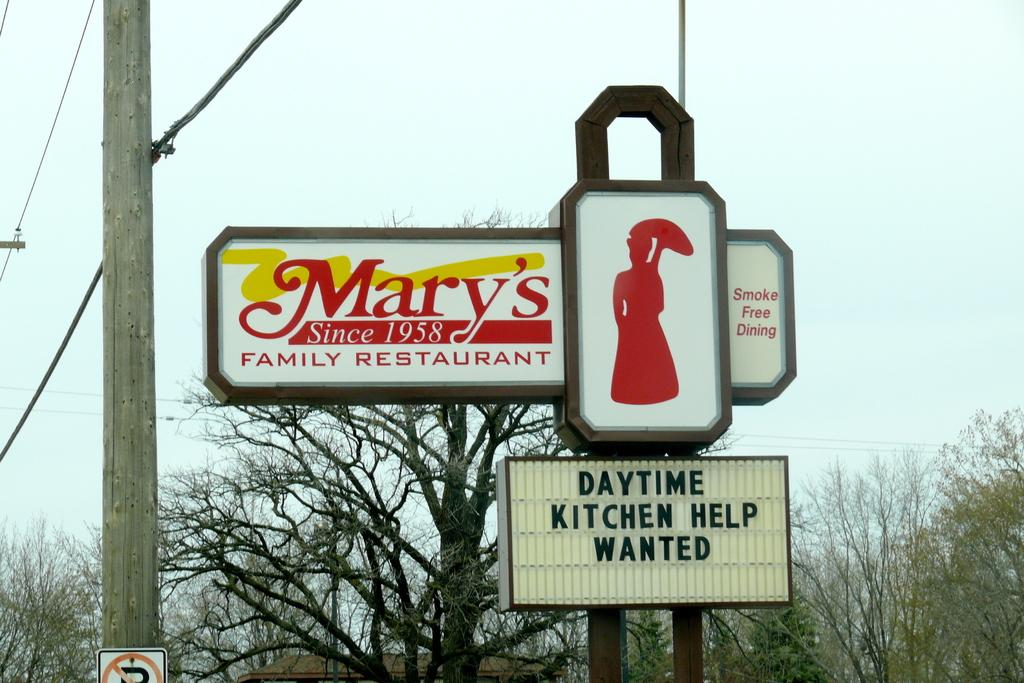What is attached to the poles in the image? There are boards on the poles in the image. What else can be seen in the image besides the boards on the poles? Electric wires are visible in the image. What type of natural vegetation is present in the image? There are trees in the image. What structure is covered by the roof in the image? The roof is present in the image, but the specific structure it covers is not mentioned in the facts. What is visible in the background of the image? The sky is visible in the image. What type of soap is being used to wash the corn on the plate in the image? There is no soap, corn, or plate present in the image. 